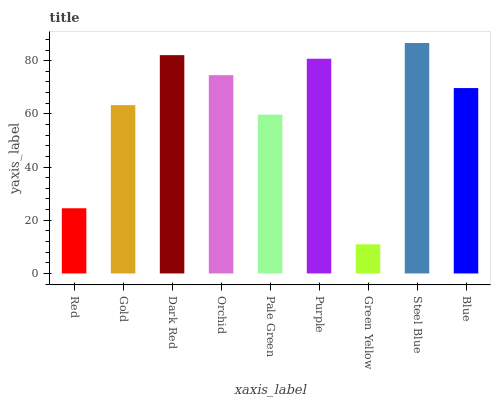Is Green Yellow the minimum?
Answer yes or no. Yes. Is Steel Blue the maximum?
Answer yes or no. Yes. Is Gold the minimum?
Answer yes or no. No. Is Gold the maximum?
Answer yes or no. No. Is Gold greater than Red?
Answer yes or no. Yes. Is Red less than Gold?
Answer yes or no. Yes. Is Red greater than Gold?
Answer yes or no. No. Is Gold less than Red?
Answer yes or no. No. Is Blue the high median?
Answer yes or no. Yes. Is Blue the low median?
Answer yes or no. Yes. Is Red the high median?
Answer yes or no. No. Is Red the low median?
Answer yes or no. No. 